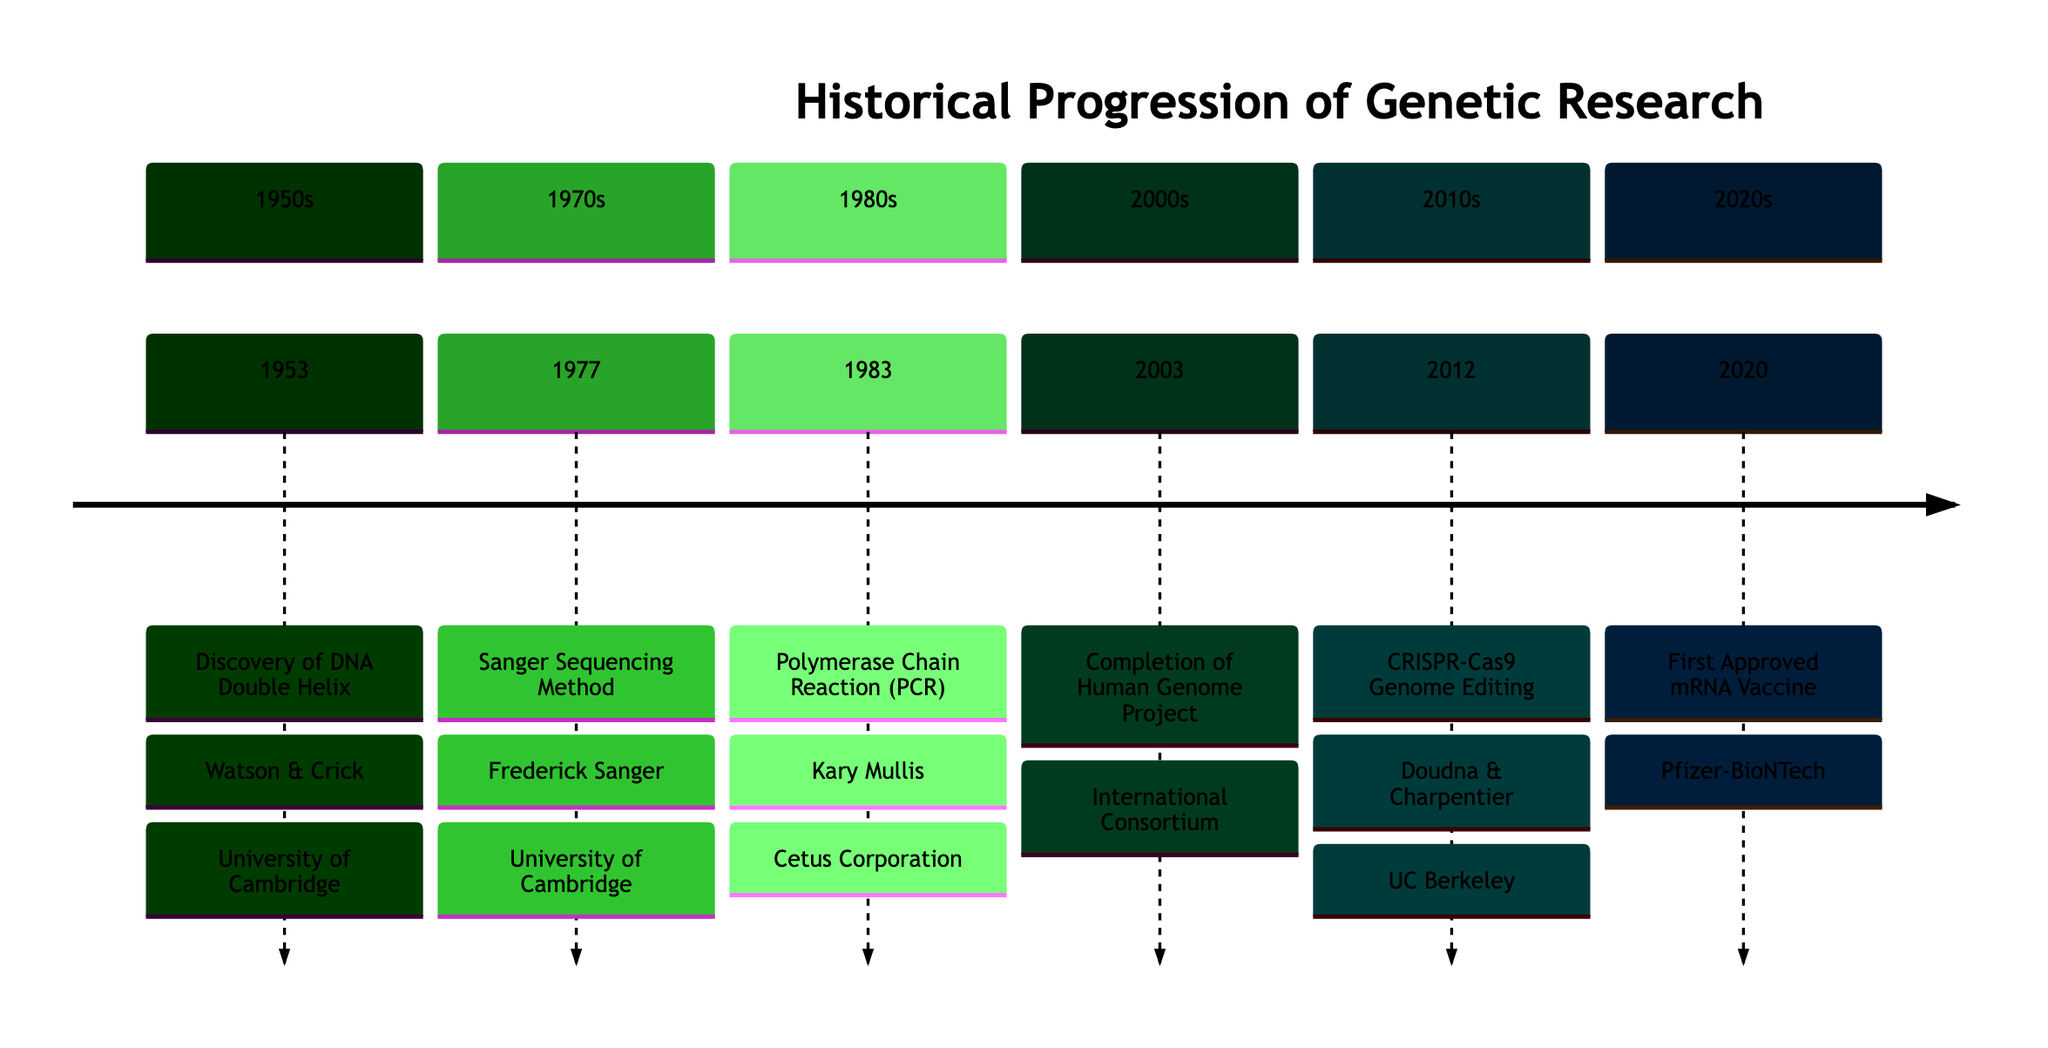What year was the discovery of the DNA double helix? The diagram indicates that the discovery of the DNA double helix occurred in the year 1953. This is found in the section labeled 1950s, which clearly states "1953 : Discovery of DNA Double Helix".
Answer: 1953 Who developed the Sanger sequencing method? In the 1977 section of the diagram, it states "Sanger Sequencing Method : Frederick Sanger". Therefore, the developer of the Sanger sequencing method is Frederick Sanger.
Answer: Frederick Sanger What institution is associated with the completion of the Human Genome Project? According to the diagram under the 2003 entry, the completion of the Human Genome Project is linked to the "International Human Genome Sequencing Consortium". Therefore, that's the institution associated with this milestone.
Answer: International Human Genome Sequencing Consortium How many major discoveries are included in the timeline? By examining the entries provided in the timeline, there are a total of six discoveries listed, specifically from the years 1953, 1977, 1983, 2003, 2012, and 2020. Thus, the total count is six.
Answer: 6 Which discovery marked the introduction of a genome editing method? The diagram specifies in the 2012 section that the introduction of the CRISPR-Cas9 genome editing method is attributed to Jennifer Doudna and Emmanuelle Charpentier. Therefore, this discovery marked the introduction of a genome editing method.
Answer: CRISPR-Cas9 Genome Editing What significant breakthrough related to mRNA occurred in 2020? The entry in the timeline for the year 2020 mentions the "First Approved mRNA Vaccine". This indicates that the significant breakthrough concerning mRNA technology in that year is the approval of an mRNA vaccine.
Answer: First Approved mRNA Vaccine What is the main focus of the timeline? The overall content of the timeline concerns the historical progression of genetic research, particularly critical discoveries and advancements in the field throughout the decades. This is established in the title of the diagram.
Answer: Historical Progression of Genetic Research Who were the main researchers behind the DNA double helix discovery? The diagram in the 1953 section notes that the researchers involved were "Watson & Crick". This indicates that they were the main individuals responsible for this discovery.
Answer: Watson & Crick What decade saw the development of the Polymerase Chain Reaction (PCR)? Referring to the entry for 1983 in the timeline, it is noted under the 1980s section that PCR was developed. Thus, the development of PCR occurred in the 1980s.
Answer: 1980s 